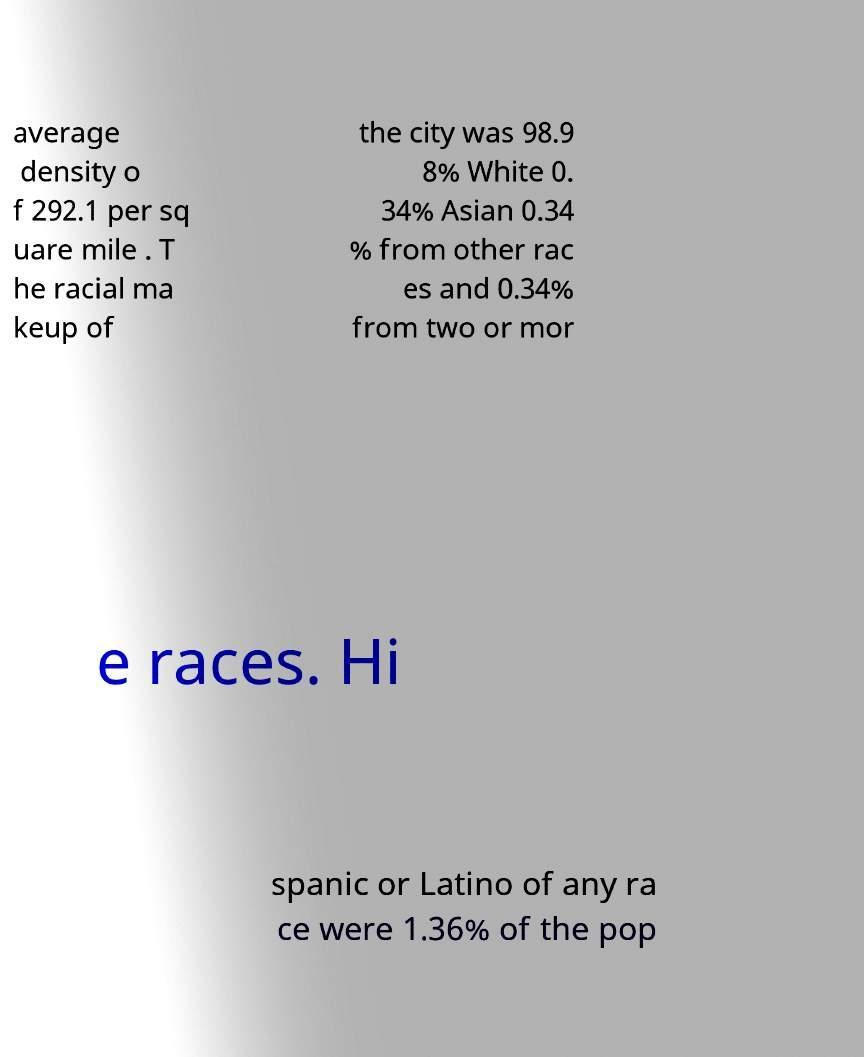What messages or text are displayed in this image? I need them in a readable, typed format. average density o f 292.1 per sq uare mile . T he racial ma keup of the city was 98.9 8% White 0. 34% Asian 0.34 % from other rac es and 0.34% from two or mor e races. Hi spanic or Latino of any ra ce were 1.36% of the pop 